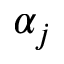<formula> <loc_0><loc_0><loc_500><loc_500>\alpha _ { j }</formula> 